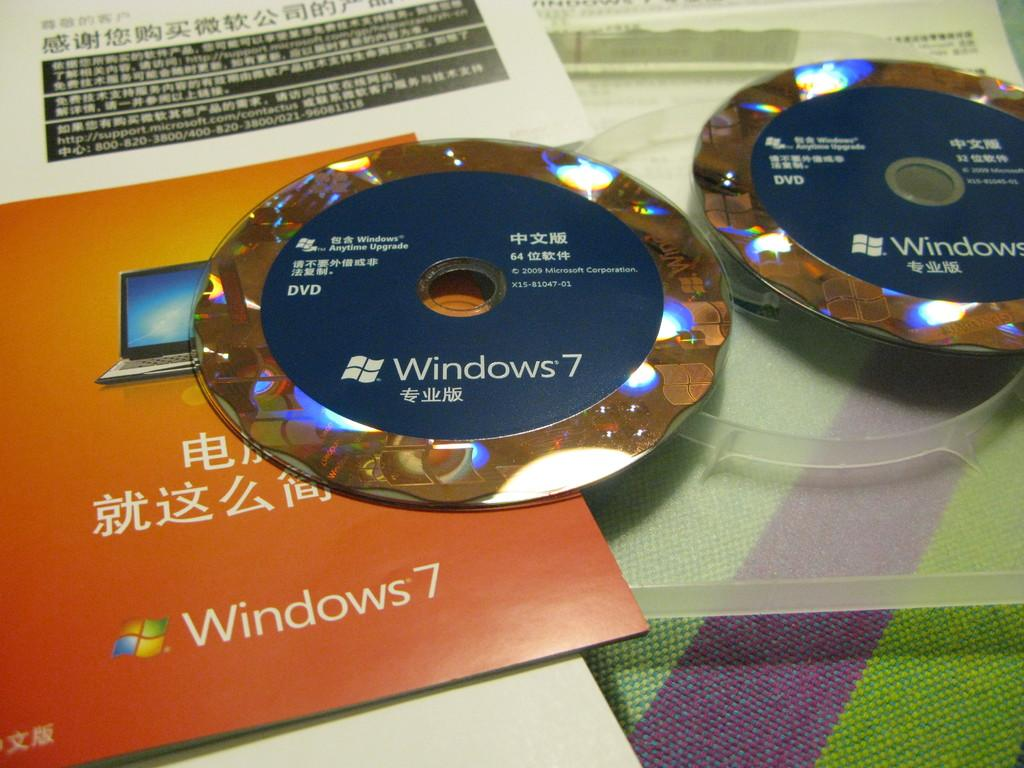<image>
Provide a brief description of the given image. A pair of CDs that are labeled for Windows 7 